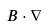Convert formula to latex. <formula><loc_0><loc_0><loc_500><loc_500>B \cdot \nabla</formula> 